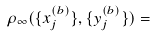<formula> <loc_0><loc_0><loc_500><loc_500>\rho _ { \infty } ( \{ x _ { j } ^ { ( b ) } \} , \{ y _ { j } ^ { ( b ) } \} ) =</formula> 